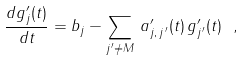<formula> <loc_0><loc_0><loc_500><loc_500>\frac { d g ^ { \prime } _ { j } ( t ) } { d t } = b _ { j } - \sum _ { j ^ { \, \prime } \neq M } \, a ^ { \prime } _ { j , \, j ^ { \, \prime } } ( t ) \, g ^ { \prime } _ { j ^ { \, \prime } } ( t ) \ ,</formula> 